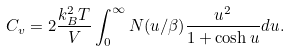Convert formula to latex. <formula><loc_0><loc_0><loc_500><loc_500>C _ { v } = 2 \frac { k _ { B } ^ { 2 } T } { V } \int _ { 0 } ^ { \infty } N ( u / \beta ) \frac { u ^ { 2 } } { 1 + \cosh u } d u .</formula> 